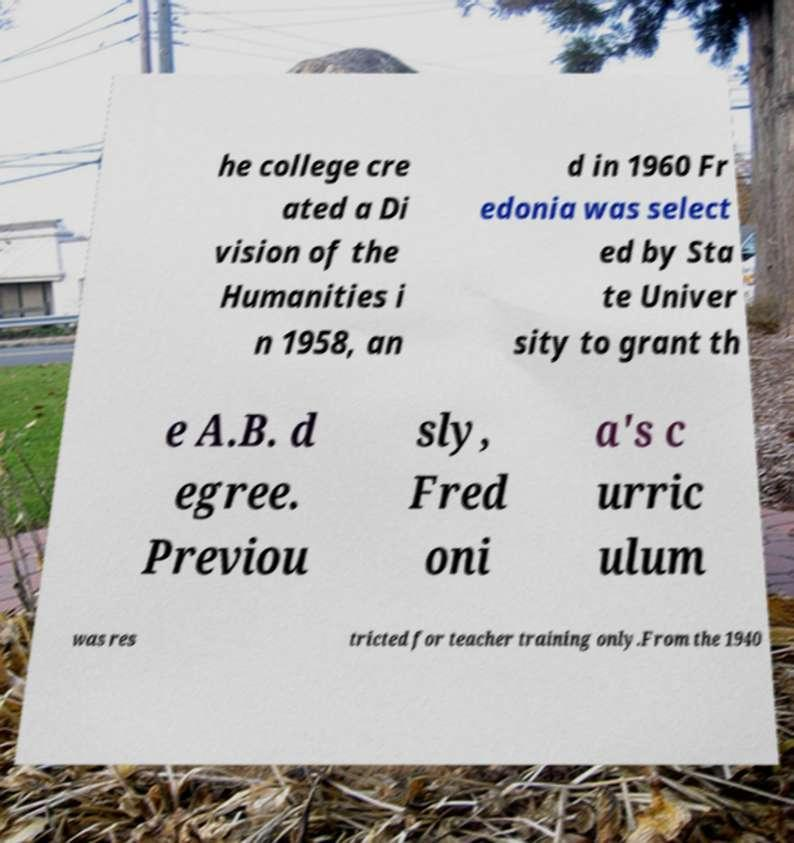Please identify and transcribe the text found in this image. he college cre ated a Di vision of the Humanities i n 1958, an d in 1960 Fr edonia was select ed by Sta te Univer sity to grant th e A.B. d egree. Previou sly, Fred oni a's c urric ulum was res tricted for teacher training only.From the 1940 